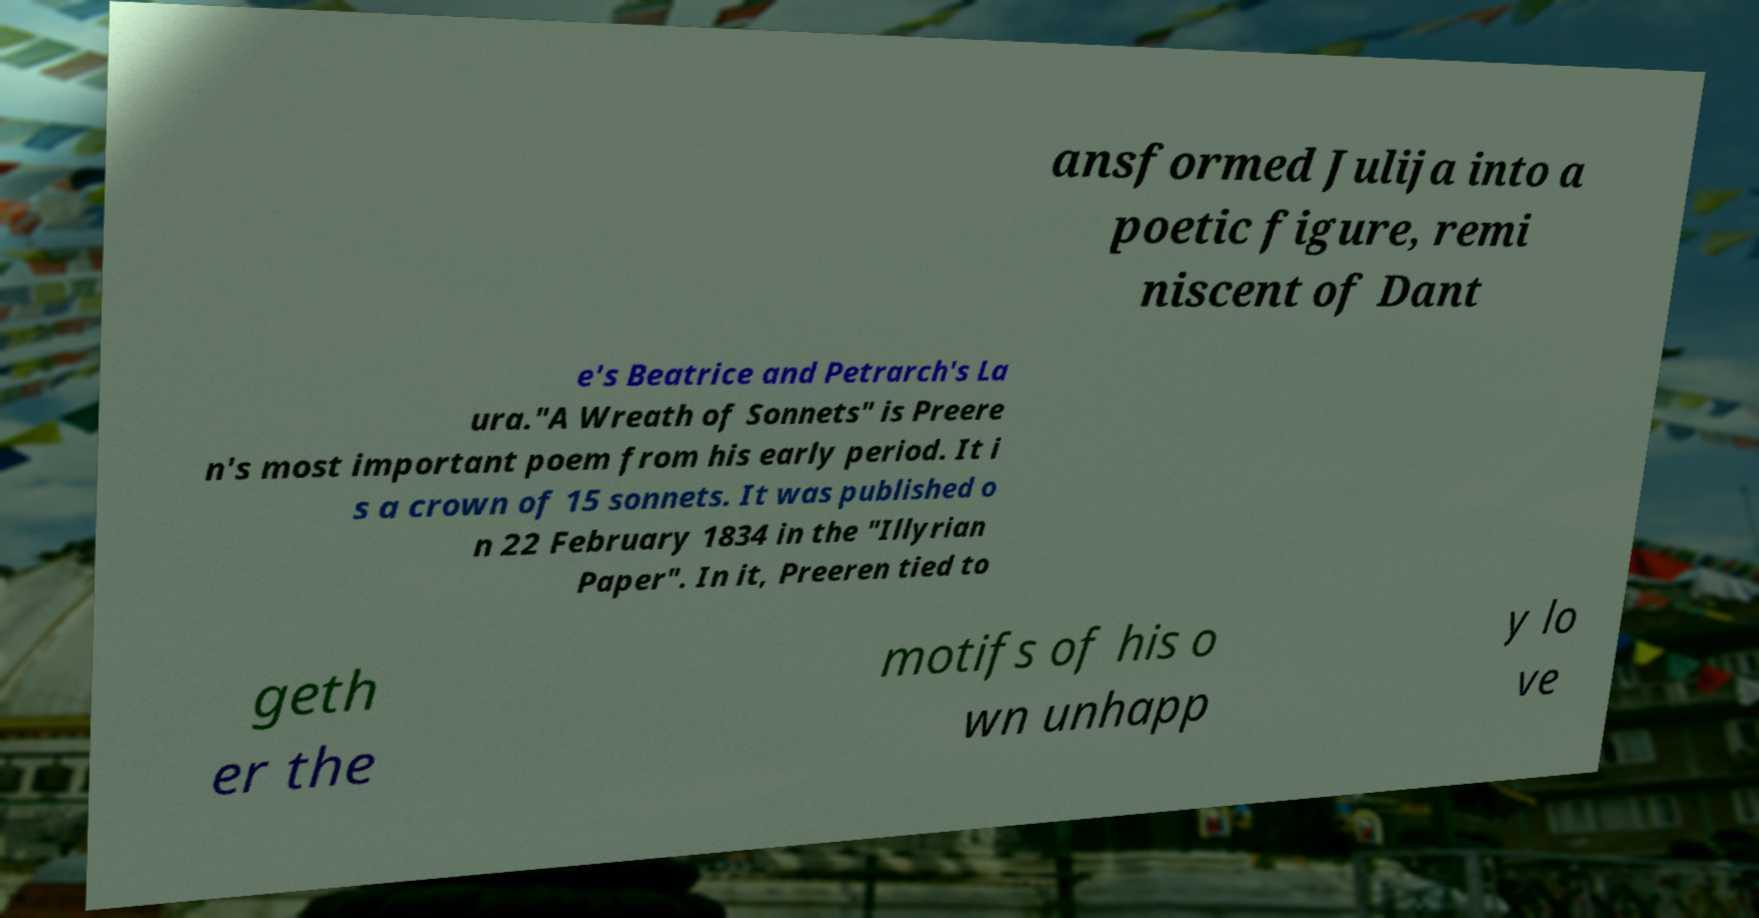I need the written content from this picture converted into text. Can you do that? ansformed Julija into a poetic figure, remi niscent of Dant e's Beatrice and Petrarch's La ura."A Wreath of Sonnets" is Preere n's most important poem from his early period. It i s a crown of 15 sonnets. It was published o n 22 February 1834 in the "Illyrian Paper". In it, Preeren tied to geth er the motifs of his o wn unhapp y lo ve 